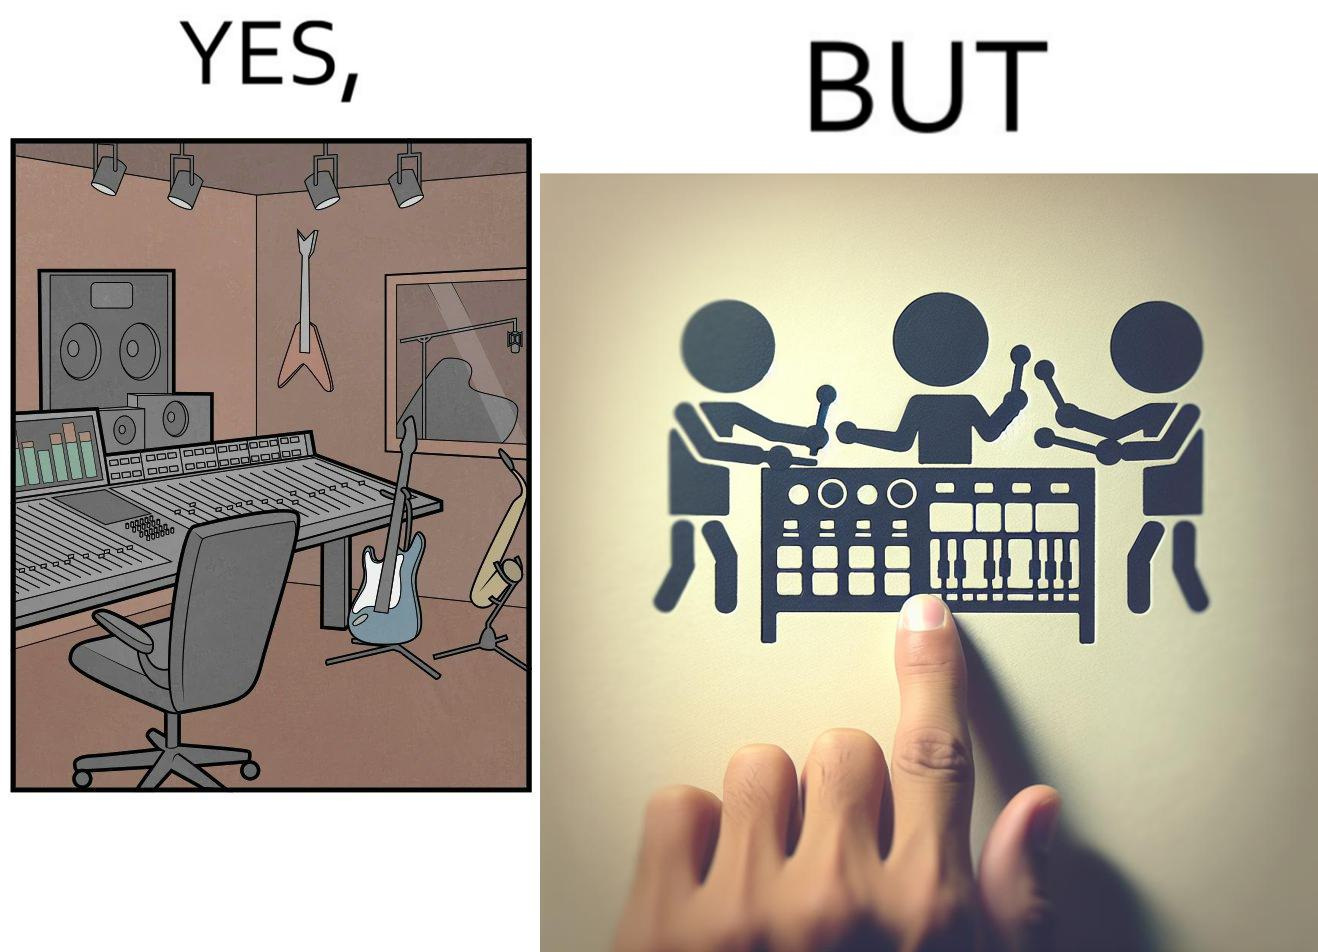Describe what you see in this image. The image overall is funny because even though people have great music studios and instruments to create and record music, they use electronic replacements of the musical instruments to achieve the task. 